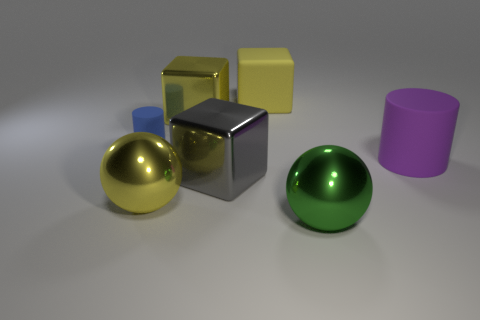Add 3 big rubber cylinders. How many objects exist? 10 Subtract all matte blocks. How many blocks are left? 2 Subtract all yellow cubes. How many cubes are left? 1 Subtract all blocks. How many objects are left? 4 Subtract 1 balls. How many balls are left? 1 Subtract all purple spheres. Subtract all cyan cylinders. How many spheres are left? 2 Subtract all yellow spheres. How many purple cylinders are left? 1 Subtract all tiny rubber things. Subtract all purple rubber cylinders. How many objects are left? 5 Add 3 matte objects. How many matte objects are left? 6 Add 7 purple things. How many purple things exist? 8 